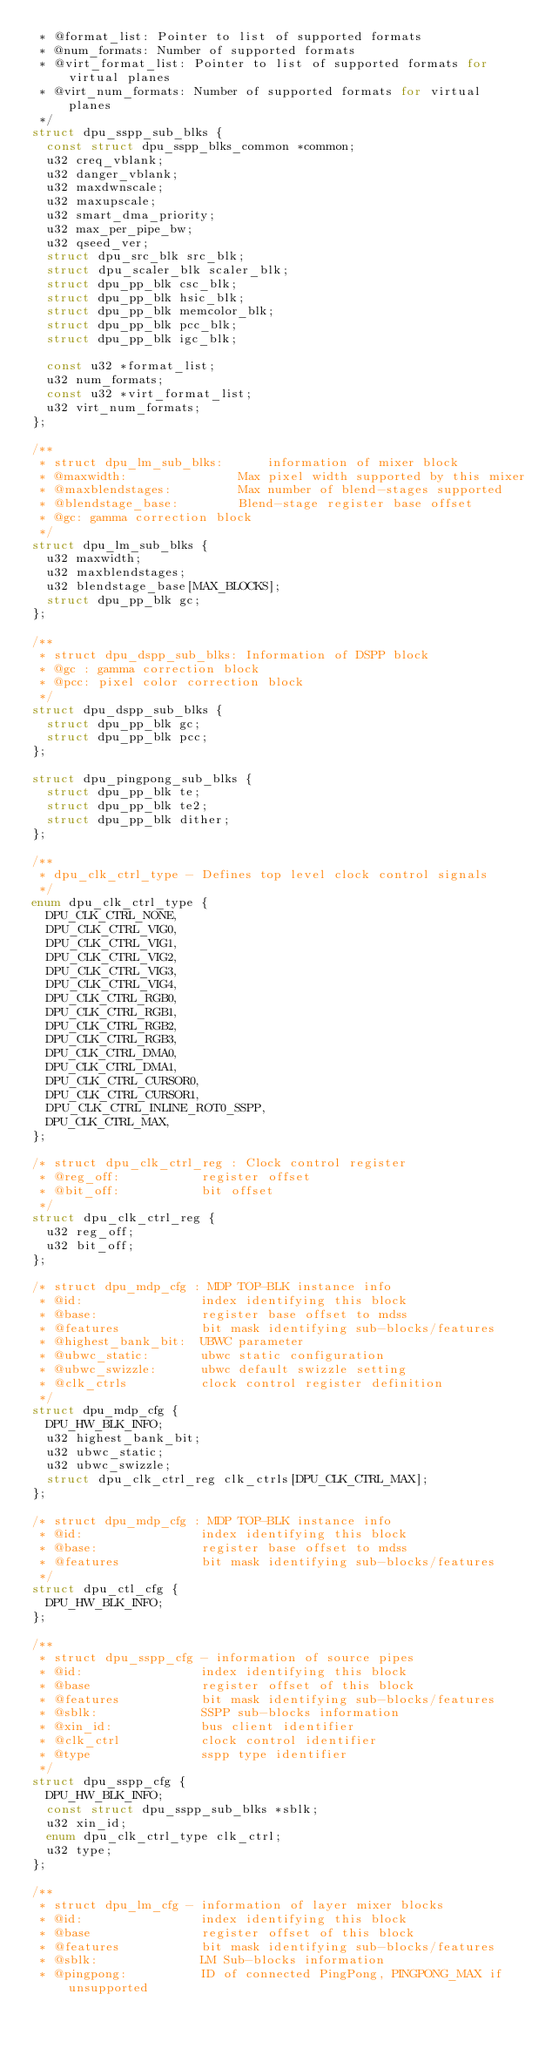Convert code to text. <code><loc_0><loc_0><loc_500><loc_500><_C_> * @format_list: Pointer to list of supported formats
 * @num_formats: Number of supported formats
 * @virt_format_list: Pointer to list of supported formats for virtual planes
 * @virt_num_formats: Number of supported formats for virtual planes
 */
struct dpu_sspp_sub_blks {
	const struct dpu_sspp_blks_common *common;
	u32 creq_vblank;
	u32 danger_vblank;
	u32 maxdwnscale;
	u32 maxupscale;
	u32 smart_dma_priority;
	u32 max_per_pipe_bw;
	u32 qseed_ver;
	struct dpu_src_blk src_blk;
	struct dpu_scaler_blk scaler_blk;
	struct dpu_pp_blk csc_blk;
	struct dpu_pp_blk hsic_blk;
	struct dpu_pp_blk memcolor_blk;
	struct dpu_pp_blk pcc_blk;
	struct dpu_pp_blk igc_blk;

	const u32 *format_list;
	u32 num_formats;
	const u32 *virt_format_list;
	u32 virt_num_formats;
};

/**
 * struct dpu_lm_sub_blks:      information of mixer block
 * @maxwidth:               Max pixel width supported by this mixer
 * @maxblendstages:         Max number of blend-stages supported
 * @blendstage_base:        Blend-stage register base offset
 * @gc: gamma correction block
 */
struct dpu_lm_sub_blks {
	u32 maxwidth;
	u32 maxblendstages;
	u32 blendstage_base[MAX_BLOCKS];
	struct dpu_pp_blk gc;
};

/**
 * struct dpu_dspp_sub_blks: Information of DSPP block
 * @gc : gamma correction block
 * @pcc: pixel color correction block
 */
struct dpu_dspp_sub_blks {
	struct dpu_pp_blk gc;
	struct dpu_pp_blk pcc;
};

struct dpu_pingpong_sub_blks {
	struct dpu_pp_blk te;
	struct dpu_pp_blk te2;
	struct dpu_pp_blk dither;
};

/**
 * dpu_clk_ctrl_type - Defines top level clock control signals
 */
enum dpu_clk_ctrl_type {
	DPU_CLK_CTRL_NONE,
	DPU_CLK_CTRL_VIG0,
	DPU_CLK_CTRL_VIG1,
	DPU_CLK_CTRL_VIG2,
	DPU_CLK_CTRL_VIG3,
	DPU_CLK_CTRL_VIG4,
	DPU_CLK_CTRL_RGB0,
	DPU_CLK_CTRL_RGB1,
	DPU_CLK_CTRL_RGB2,
	DPU_CLK_CTRL_RGB3,
	DPU_CLK_CTRL_DMA0,
	DPU_CLK_CTRL_DMA1,
	DPU_CLK_CTRL_CURSOR0,
	DPU_CLK_CTRL_CURSOR1,
	DPU_CLK_CTRL_INLINE_ROT0_SSPP,
	DPU_CLK_CTRL_MAX,
};

/* struct dpu_clk_ctrl_reg : Clock control register
 * @reg_off:           register offset
 * @bit_off:           bit offset
 */
struct dpu_clk_ctrl_reg {
	u32 reg_off;
	u32 bit_off;
};

/* struct dpu_mdp_cfg : MDP TOP-BLK instance info
 * @id:                index identifying this block
 * @base:              register base offset to mdss
 * @features           bit mask identifying sub-blocks/features
 * @highest_bank_bit:  UBWC parameter
 * @ubwc_static:       ubwc static configuration
 * @ubwc_swizzle:      ubwc default swizzle setting
 * @clk_ctrls          clock control register definition
 */
struct dpu_mdp_cfg {
	DPU_HW_BLK_INFO;
	u32 highest_bank_bit;
	u32 ubwc_static;
	u32 ubwc_swizzle;
	struct dpu_clk_ctrl_reg clk_ctrls[DPU_CLK_CTRL_MAX];
};

/* struct dpu_mdp_cfg : MDP TOP-BLK instance info
 * @id:                index identifying this block
 * @base:              register base offset to mdss
 * @features           bit mask identifying sub-blocks/features
 */
struct dpu_ctl_cfg {
	DPU_HW_BLK_INFO;
};

/**
 * struct dpu_sspp_cfg - information of source pipes
 * @id:                index identifying this block
 * @base               register offset of this block
 * @features           bit mask identifying sub-blocks/features
 * @sblk:              SSPP sub-blocks information
 * @xin_id:            bus client identifier
 * @clk_ctrl           clock control identifier
 * @type               sspp type identifier
 */
struct dpu_sspp_cfg {
	DPU_HW_BLK_INFO;
	const struct dpu_sspp_sub_blks *sblk;
	u32 xin_id;
	enum dpu_clk_ctrl_type clk_ctrl;
	u32 type;
};

/**
 * struct dpu_lm_cfg - information of layer mixer blocks
 * @id:                index identifying this block
 * @base               register offset of this block
 * @features           bit mask identifying sub-blocks/features
 * @sblk:              LM Sub-blocks information
 * @pingpong:          ID of connected PingPong, PINGPONG_MAX if unsupported</code> 